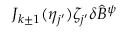Convert formula to latex. <formula><loc_0><loc_0><loc_500><loc_500>J _ { k \pm 1 } ( \eta _ { j ^ { \prime } } ) \zeta _ { j ^ { \prime } } \delta \hat { B } ^ { \psi }</formula> 